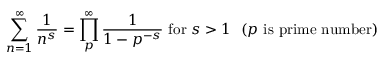<formula> <loc_0><loc_0><loc_500><loc_500>\sum _ { n = 1 } ^ { \infty } { \frac { 1 } { n ^ { s } } } = \prod _ { p } ^ { \infty } { \frac { 1 } { 1 - p ^ { - s } } } { f o r } s > 1 \, \ ( p { i s p r i m e n u m b e r ) }</formula> 